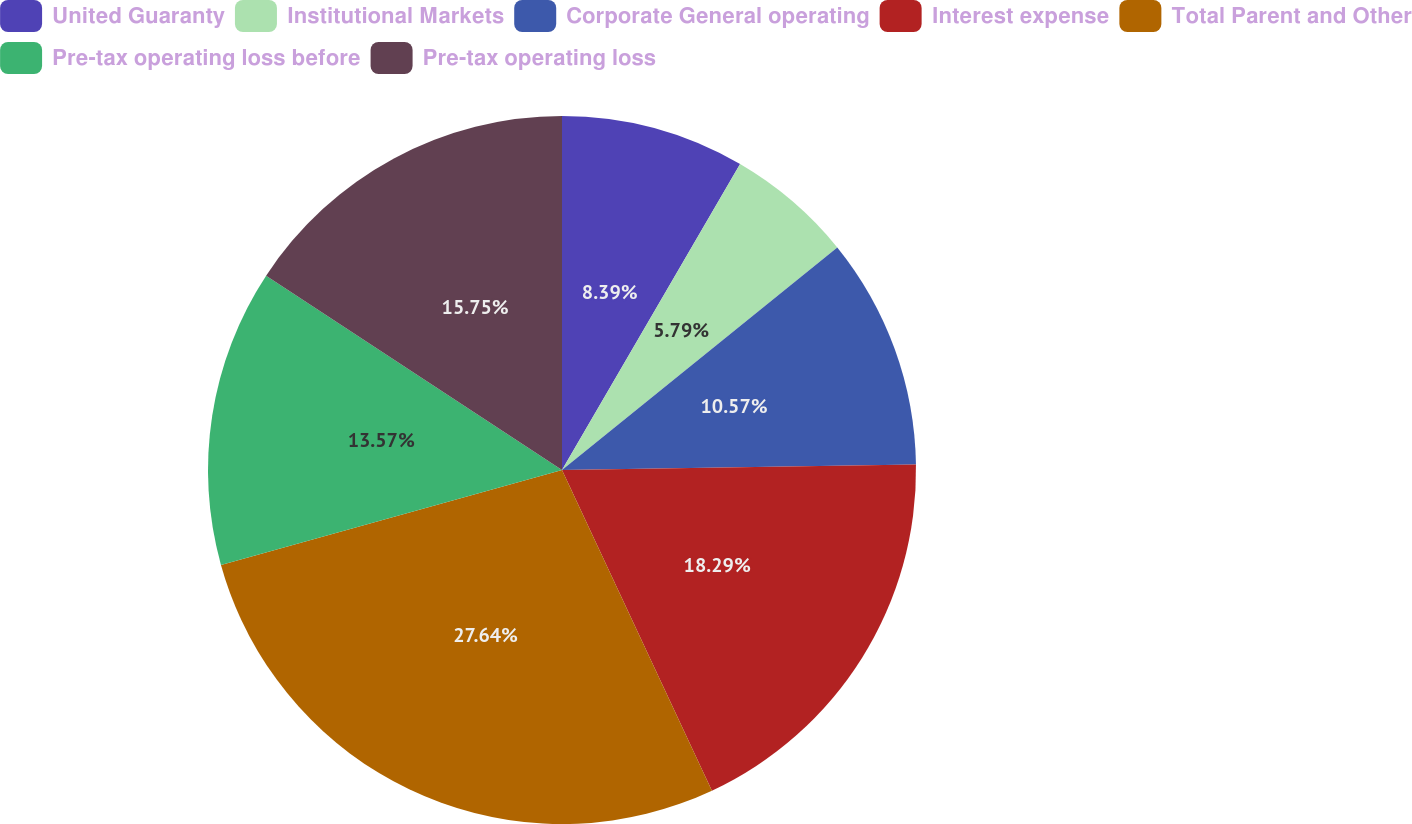Convert chart to OTSL. <chart><loc_0><loc_0><loc_500><loc_500><pie_chart><fcel>United Guaranty<fcel>Institutional Markets<fcel>Corporate General operating<fcel>Interest expense<fcel>Total Parent and Other<fcel>Pre-tax operating loss before<fcel>Pre-tax operating loss<nl><fcel>8.39%<fcel>5.79%<fcel>10.57%<fcel>18.29%<fcel>27.64%<fcel>13.57%<fcel>15.75%<nl></chart> 